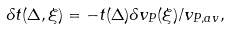Convert formula to latex. <formula><loc_0><loc_0><loc_500><loc_500>\delta t ( \Delta , \xi ) = - t ( \Delta ) \delta v _ { P } ( \xi ) / v _ { P , a v } ,</formula> 